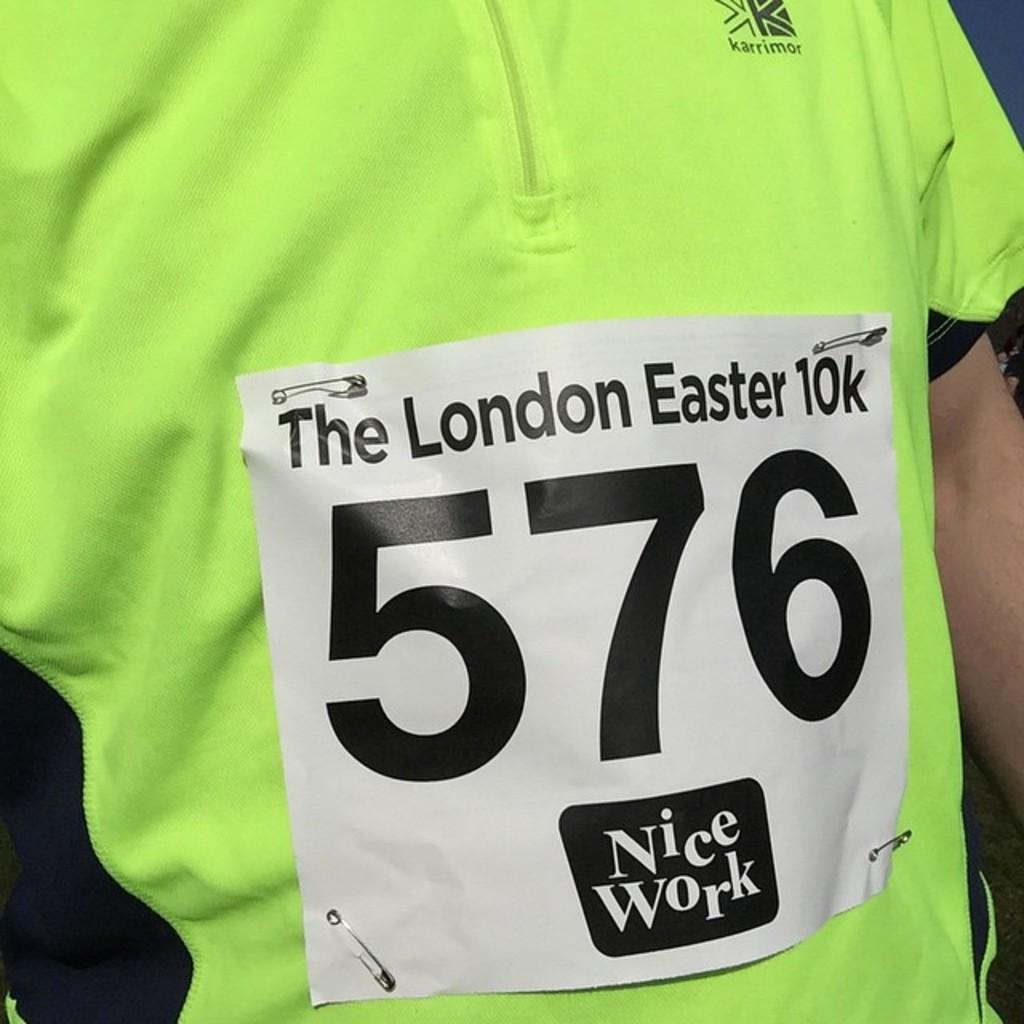<image>
Give a short and clear explanation of the subsequent image. A runner competes in the London Easter 10k race wearing the number 576. 